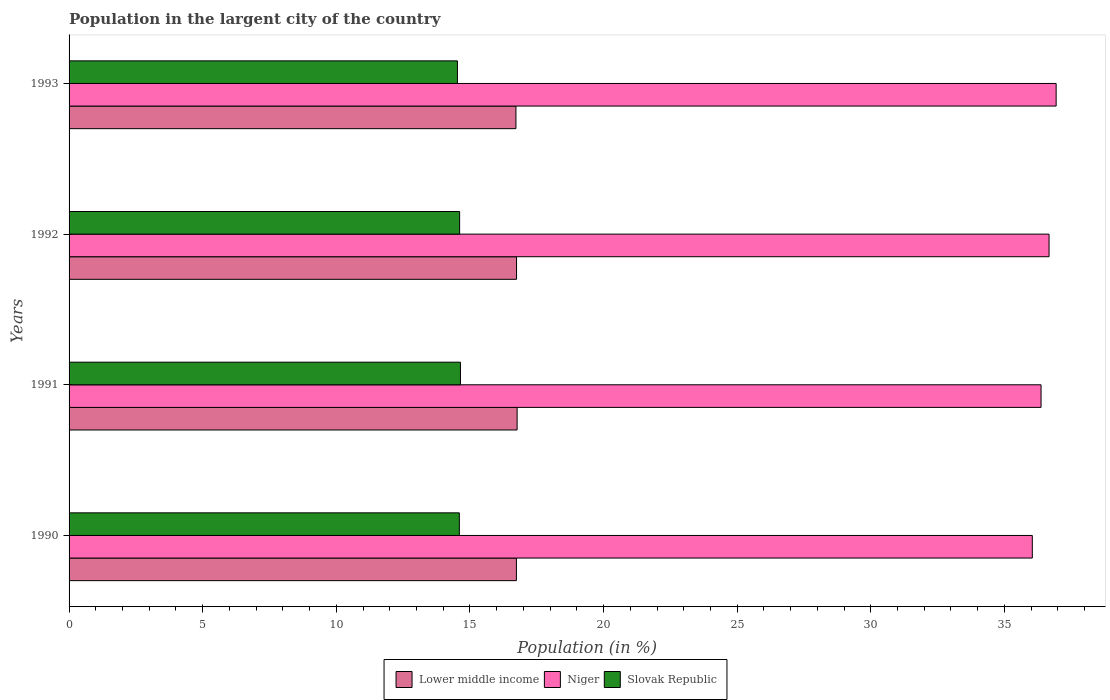How many different coloured bars are there?
Ensure brevity in your answer.  3. How many groups of bars are there?
Keep it short and to the point. 4. How many bars are there on the 3rd tick from the top?
Provide a succinct answer. 3. How many bars are there on the 2nd tick from the bottom?
Provide a short and direct response. 3. What is the label of the 3rd group of bars from the top?
Provide a short and direct response. 1991. What is the percentage of population in the largent city in Niger in 1992?
Your answer should be compact. 36.67. Across all years, what is the maximum percentage of population in the largent city in Niger?
Ensure brevity in your answer.  36.93. Across all years, what is the minimum percentage of population in the largent city in Niger?
Provide a short and direct response. 36.04. In which year was the percentage of population in the largent city in Niger maximum?
Make the answer very short. 1993. What is the total percentage of population in the largent city in Lower middle income in the graph?
Ensure brevity in your answer.  66.97. What is the difference between the percentage of population in the largent city in Lower middle income in 1991 and that in 1993?
Your response must be concise. 0.04. What is the difference between the percentage of population in the largent city in Lower middle income in 1990 and the percentage of population in the largent city in Niger in 1991?
Your answer should be very brief. -19.63. What is the average percentage of population in the largent city in Niger per year?
Provide a succinct answer. 36.5. In the year 1993, what is the difference between the percentage of population in the largent city in Niger and percentage of population in the largent city in Lower middle income?
Ensure brevity in your answer.  20.21. What is the ratio of the percentage of population in the largent city in Slovak Republic in 1992 to that in 1993?
Offer a terse response. 1.01. Is the percentage of population in the largent city in Lower middle income in 1992 less than that in 1993?
Offer a very short reply. No. Is the difference between the percentage of population in the largent city in Niger in 1992 and 1993 greater than the difference between the percentage of population in the largent city in Lower middle income in 1992 and 1993?
Your answer should be compact. No. What is the difference between the highest and the second highest percentage of population in the largent city in Niger?
Your response must be concise. 0.26. What is the difference between the highest and the lowest percentage of population in the largent city in Slovak Republic?
Offer a very short reply. 0.11. What does the 1st bar from the top in 1990 represents?
Offer a very short reply. Slovak Republic. What does the 1st bar from the bottom in 1992 represents?
Your answer should be very brief. Lower middle income. Is it the case that in every year, the sum of the percentage of population in the largent city in Niger and percentage of population in the largent city in Lower middle income is greater than the percentage of population in the largent city in Slovak Republic?
Give a very brief answer. Yes. How many bars are there?
Your response must be concise. 12. How many years are there in the graph?
Your response must be concise. 4. Are the values on the major ticks of X-axis written in scientific E-notation?
Provide a succinct answer. No. How many legend labels are there?
Ensure brevity in your answer.  3. How are the legend labels stacked?
Keep it short and to the point. Horizontal. What is the title of the graph?
Offer a terse response. Population in the largent city of the country. What is the label or title of the X-axis?
Keep it short and to the point. Population (in %). What is the label or title of the Y-axis?
Offer a terse response. Years. What is the Population (in %) in Lower middle income in 1990?
Offer a very short reply. 16.74. What is the Population (in %) in Niger in 1990?
Provide a succinct answer. 36.04. What is the Population (in %) of Slovak Republic in 1990?
Your response must be concise. 14.6. What is the Population (in %) in Lower middle income in 1991?
Provide a short and direct response. 16.77. What is the Population (in %) in Niger in 1991?
Offer a terse response. 36.37. What is the Population (in %) of Slovak Republic in 1991?
Offer a terse response. 14.64. What is the Population (in %) of Lower middle income in 1992?
Give a very brief answer. 16.74. What is the Population (in %) of Niger in 1992?
Make the answer very short. 36.67. What is the Population (in %) in Slovak Republic in 1992?
Offer a terse response. 14.61. What is the Population (in %) of Lower middle income in 1993?
Your answer should be very brief. 16.72. What is the Population (in %) in Niger in 1993?
Your answer should be compact. 36.93. What is the Population (in %) in Slovak Republic in 1993?
Your response must be concise. 14.53. Across all years, what is the maximum Population (in %) in Lower middle income?
Provide a short and direct response. 16.77. Across all years, what is the maximum Population (in %) in Niger?
Offer a terse response. 36.93. Across all years, what is the maximum Population (in %) of Slovak Republic?
Make the answer very short. 14.64. Across all years, what is the minimum Population (in %) in Lower middle income?
Offer a very short reply. 16.72. Across all years, what is the minimum Population (in %) of Niger?
Provide a succinct answer. 36.04. Across all years, what is the minimum Population (in %) of Slovak Republic?
Make the answer very short. 14.53. What is the total Population (in %) in Lower middle income in the graph?
Offer a terse response. 66.97. What is the total Population (in %) of Niger in the graph?
Give a very brief answer. 146.02. What is the total Population (in %) of Slovak Republic in the graph?
Provide a short and direct response. 58.39. What is the difference between the Population (in %) of Lower middle income in 1990 and that in 1991?
Your response must be concise. -0.03. What is the difference between the Population (in %) of Niger in 1990 and that in 1991?
Give a very brief answer. -0.33. What is the difference between the Population (in %) of Slovak Republic in 1990 and that in 1991?
Provide a short and direct response. -0.04. What is the difference between the Population (in %) of Lower middle income in 1990 and that in 1992?
Make the answer very short. -0. What is the difference between the Population (in %) in Niger in 1990 and that in 1992?
Give a very brief answer. -0.63. What is the difference between the Population (in %) of Slovak Republic in 1990 and that in 1992?
Provide a succinct answer. -0.01. What is the difference between the Population (in %) of Lower middle income in 1990 and that in 1993?
Give a very brief answer. 0.02. What is the difference between the Population (in %) of Niger in 1990 and that in 1993?
Your answer should be very brief. -0.89. What is the difference between the Population (in %) in Slovak Republic in 1990 and that in 1993?
Your response must be concise. 0.07. What is the difference between the Population (in %) of Lower middle income in 1991 and that in 1992?
Your answer should be compact. 0.02. What is the difference between the Population (in %) of Niger in 1991 and that in 1992?
Provide a succinct answer. -0.3. What is the difference between the Population (in %) in Slovak Republic in 1991 and that in 1992?
Your answer should be compact. 0.03. What is the difference between the Population (in %) of Lower middle income in 1991 and that in 1993?
Offer a very short reply. 0.04. What is the difference between the Population (in %) of Niger in 1991 and that in 1993?
Give a very brief answer. -0.56. What is the difference between the Population (in %) of Slovak Republic in 1991 and that in 1993?
Keep it short and to the point. 0.11. What is the difference between the Population (in %) of Lower middle income in 1992 and that in 1993?
Provide a succinct answer. 0.02. What is the difference between the Population (in %) in Niger in 1992 and that in 1993?
Your answer should be compact. -0.26. What is the difference between the Population (in %) in Slovak Republic in 1992 and that in 1993?
Give a very brief answer. 0.08. What is the difference between the Population (in %) of Lower middle income in 1990 and the Population (in %) of Niger in 1991?
Make the answer very short. -19.63. What is the difference between the Population (in %) of Lower middle income in 1990 and the Population (in %) of Slovak Republic in 1991?
Provide a succinct answer. 2.09. What is the difference between the Population (in %) of Niger in 1990 and the Population (in %) of Slovak Republic in 1991?
Offer a terse response. 21.4. What is the difference between the Population (in %) of Lower middle income in 1990 and the Population (in %) of Niger in 1992?
Keep it short and to the point. -19.93. What is the difference between the Population (in %) in Lower middle income in 1990 and the Population (in %) in Slovak Republic in 1992?
Offer a terse response. 2.13. What is the difference between the Population (in %) in Niger in 1990 and the Population (in %) in Slovak Republic in 1992?
Make the answer very short. 21.43. What is the difference between the Population (in %) in Lower middle income in 1990 and the Population (in %) in Niger in 1993?
Keep it short and to the point. -20.2. What is the difference between the Population (in %) in Lower middle income in 1990 and the Population (in %) in Slovak Republic in 1993?
Your answer should be compact. 2.21. What is the difference between the Population (in %) of Niger in 1990 and the Population (in %) of Slovak Republic in 1993?
Offer a terse response. 21.51. What is the difference between the Population (in %) of Lower middle income in 1991 and the Population (in %) of Niger in 1992?
Offer a terse response. -19.9. What is the difference between the Population (in %) of Lower middle income in 1991 and the Population (in %) of Slovak Republic in 1992?
Your answer should be compact. 2.15. What is the difference between the Population (in %) of Niger in 1991 and the Population (in %) of Slovak Republic in 1992?
Provide a short and direct response. 21.76. What is the difference between the Population (in %) of Lower middle income in 1991 and the Population (in %) of Niger in 1993?
Your answer should be very brief. -20.17. What is the difference between the Population (in %) of Lower middle income in 1991 and the Population (in %) of Slovak Republic in 1993?
Give a very brief answer. 2.23. What is the difference between the Population (in %) of Niger in 1991 and the Population (in %) of Slovak Republic in 1993?
Make the answer very short. 21.84. What is the difference between the Population (in %) of Lower middle income in 1992 and the Population (in %) of Niger in 1993?
Keep it short and to the point. -20.19. What is the difference between the Population (in %) in Lower middle income in 1992 and the Population (in %) in Slovak Republic in 1993?
Provide a short and direct response. 2.21. What is the difference between the Population (in %) in Niger in 1992 and the Population (in %) in Slovak Republic in 1993?
Your response must be concise. 22.14. What is the average Population (in %) of Lower middle income per year?
Your answer should be compact. 16.74. What is the average Population (in %) in Niger per year?
Offer a very short reply. 36.5. What is the average Population (in %) of Slovak Republic per year?
Your answer should be very brief. 14.6. In the year 1990, what is the difference between the Population (in %) in Lower middle income and Population (in %) in Niger?
Your answer should be very brief. -19.3. In the year 1990, what is the difference between the Population (in %) in Lower middle income and Population (in %) in Slovak Republic?
Your response must be concise. 2.14. In the year 1990, what is the difference between the Population (in %) in Niger and Population (in %) in Slovak Republic?
Your answer should be very brief. 21.44. In the year 1991, what is the difference between the Population (in %) in Lower middle income and Population (in %) in Niger?
Give a very brief answer. -19.6. In the year 1991, what is the difference between the Population (in %) of Lower middle income and Population (in %) of Slovak Republic?
Your answer should be compact. 2.12. In the year 1991, what is the difference between the Population (in %) in Niger and Population (in %) in Slovak Republic?
Ensure brevity in your answer.  21.73. In the year 1992, what is the difference between the Population (in %) in Lower middle income and Population (in %) in Niger?
Give a very brief answer. -19.93. In the year 1992, what is the difference between the Population (in %) of Lower middle income and Population (in %) of Slovak Republic?
Keep it short and to the point. 2.13. In the year 1992, what is the difference between the Population (in %) of Niger and Population (in %) of Slovak Republic?
Ensure brevity in your answer.  22.06. In the year 1993, what is the difference between the Population (in %) of Lower middle income and Population (in %) of Niger?
Provide a succinct answer. -20.21. In the year 1993, what is the difference between the Population (in %) of Lower middle income and Population (in %) of Slovak Republic?
Provide a succinct answer. 2.19. In the year 1993, what is the difference between the Population (in %) in Niger and Population (in %) in Slovak Republic?
Offer a terse response. 22.4. What is the ratio of the Population (in %) of Lower middle income in 1990 to that in 1991?
Offer a terse response. 1. What is the ratio of the Population (in %) in Niger in 1990 to that in 1992?
Ensure brevity in your answer.  0.98. What is the ratio of the Population (in %) in Niger in 1990 to that in 1993?
Ensure brevity in your answer.  0.98. What is the ratio of the Population (in %) of Lower middle income in 1991 to that in 1992?
Offer a very short reply. 1. What is the ratio of the Population (in %) of Niger in 1991 to that in 1993?
Give a very brief answer. 0.98. What is the ratio of the Population (in %) of Slovak Republic in 1991 to that in 1993?
Provide a succinct answer. 1.01. What is the ratio of the Population (in %) of Lower middle income in 1992 to that in 1993?
Offer a very short reply. 1. What is the ratio of the Population (in %) in Slovak Republic in 1992 to that in 1993?
Keep it short and to the point. 1.01. What is the difference between the highest and the second highest Population (in %) in Lower middle income?
Provide a succinct answer. 0.02. What is the difference between the highest and the second highest Population (in %) in Niger?
Your response must be concise. 0.26. What is the difference between the highest and the second highest Population (in %) of Slovak Republic?
Provide a succinct answer. 0.03. What is the difference between the highest and the lowest Population (in %) of Lower middle income?
Provide a succinct answer. 0.04. What is the difference between the highest and the lowest Population (in %) of Niger?
Provide a succinct answer. 0.89. What is the difference between the highest and the lowest Population (in %) of Slovak Republic?
Provide a short and direct response. 0.11. 